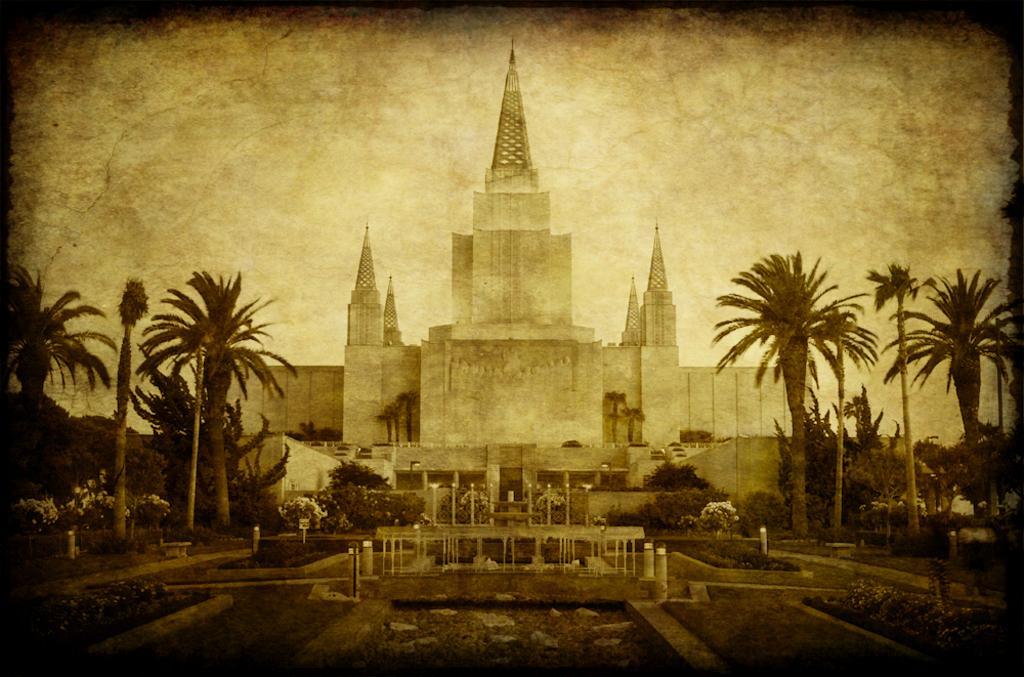Can you describe this image briefly? In this image we can see trees, plants with flowers, grass and poles. In the background we can see a building, objects and clouds in the sky. 